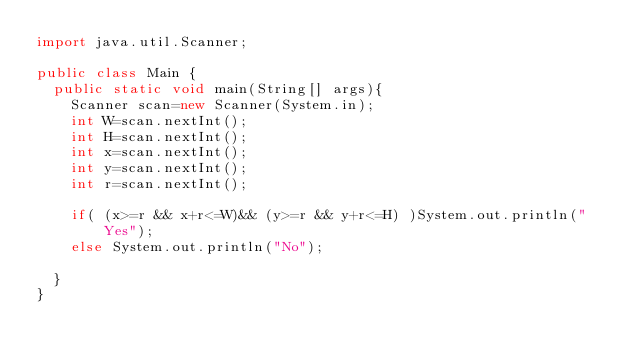<code> <loc_0><loc_0><loc_500><loc_500><_Java_>import java.util.Scanner;

public class Main {
	public static void main(String[] args){
		Scanner scan=new Scanner(System.in);
		int W=scan.nextInt();
		int H=scan.nextInt();
		int x=scan.nextInt();
		int y=scan.nextInt();
		int r=scan.nextInt();
		
		if( (x>=r && x+r<=W)&& (y>=r && y+r<=H) )System.out.println("Yes");
		else System.out.println("No");
		
	}
}
</code> 